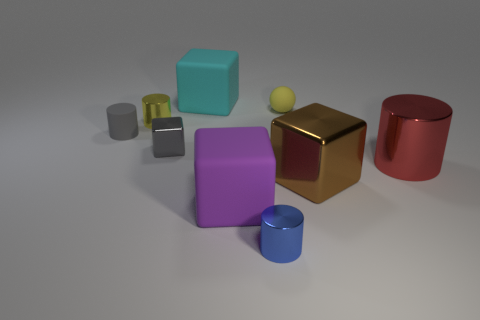What shape is the tiny metallic thing that is the same color as the tiny matte cylinder?
Your answer should be compact. Cube. There is a large object that is behind the small metal cylinder to the left of the cyan block to the left of the blue object; what is it made of?
Ensure brevity in your answer.  Rubber. What number of metal things are either small blue blocks or small spheres?
Give a very brief answer. 0. Is the small shiny cube the same color as the rubber cylinder?
Provide a short and direct response. Yes. What number of things are either tiny yellow metallic things or shiny objects behind the tiny blue object?
Provide a succinct answer. 4. Does the metallic block that is behind the brown block have the same size as the yellow matte thing?
Give a very brief answer. Yes. How many other objects are the same shape as the gray metal thing?
Offer a terse response. 3. What number of red things are either big metal blocks or small cubes?
Your answer should be very brief. 0. There is a tiny rubber thing in front of the small yellow matte thing; does it have the same color as the small metallic block?
Your response must be concise. Yes. There is a large thing that is made of the same material as the large brown block; what shape is it?
Your answer should be compact. Cylinder. 